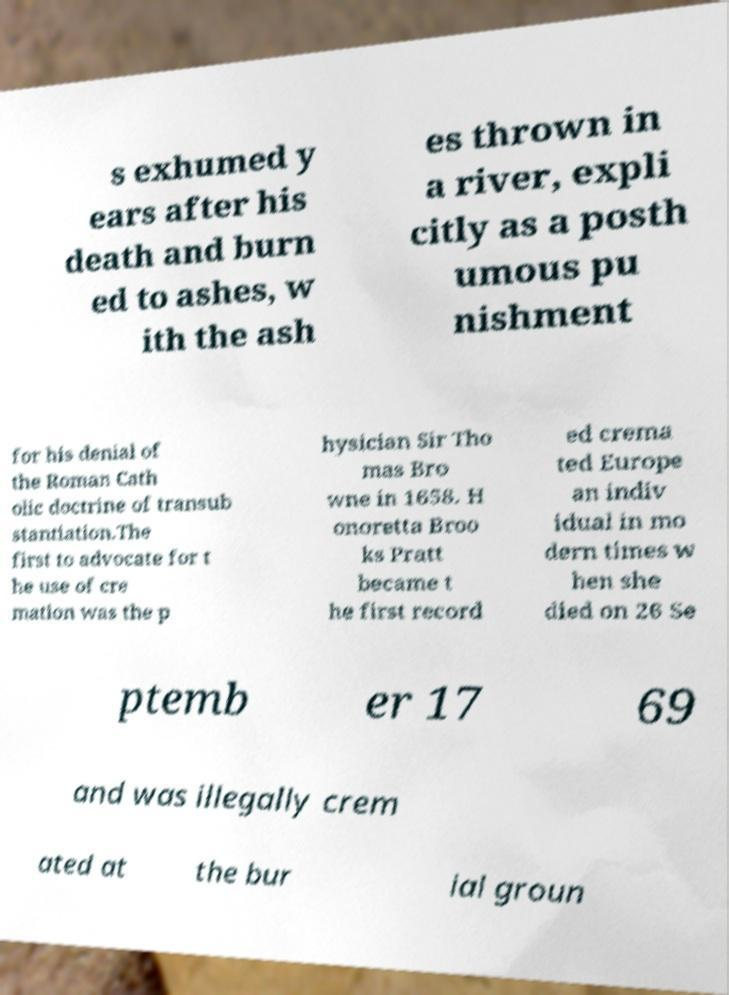Can you accurately transcribe the text from the provided image for me? s exhumed y ears after his death and burn ed to ashes, w ith the ash es thrown in a river, expli citly as a posth umous pu nishment for his denial of the Roman Cath olic doctrine of transub stantiation.The first to advocate for t he use of cre mation was the p hysician Sir Tho mas Bro wne in 1658. H onoretta Broo ks Pratt became t he first record ed crema ted Europe an indiv idual in mo dern times w hen she died on 26 Se ptemb er 17 69 and was illegally crem ated at the bur ial groun 